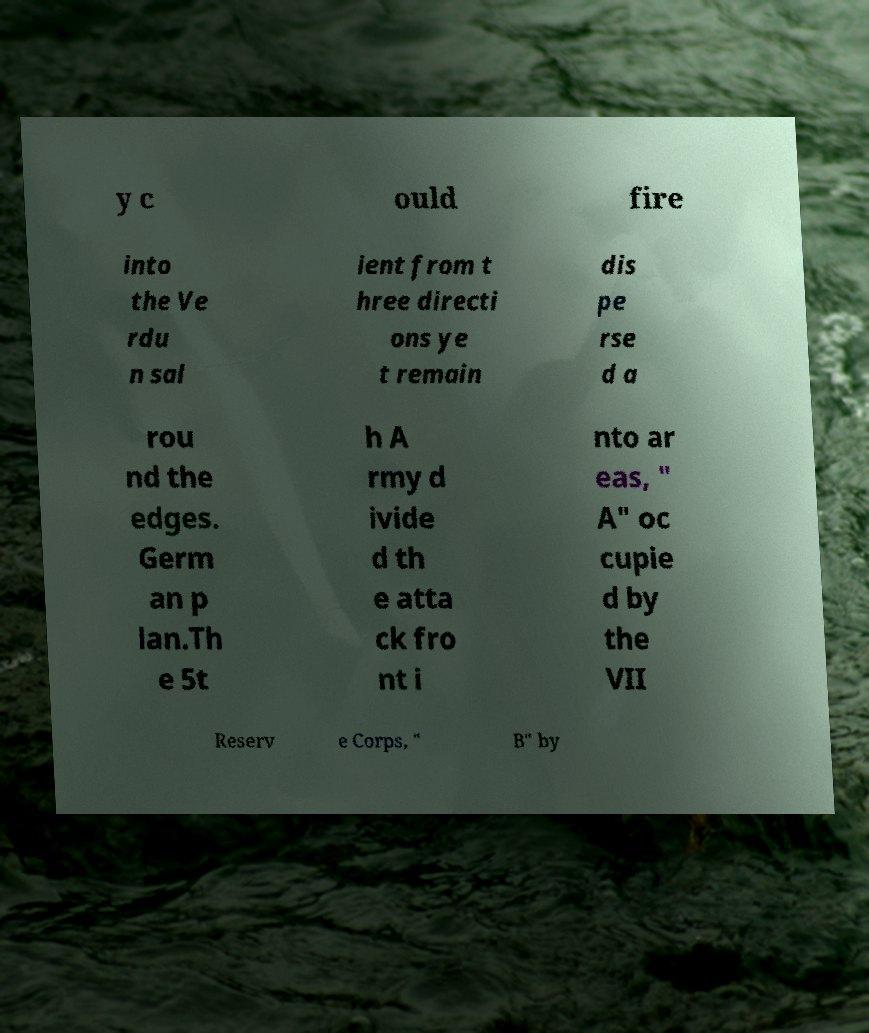Can you accurately transcribe the text from the provided image for me? y c ould fire into the Ve rdu n sal ient from t hree directi ons ye t remain dis pe rse d a rou nd the edges. Germ an p lan.Th e 5t h A rmy d ivide d th e atta ck fro nt i nto ar eas, " A" oc cupie d by the VII Reserv e Corps, " B" by 